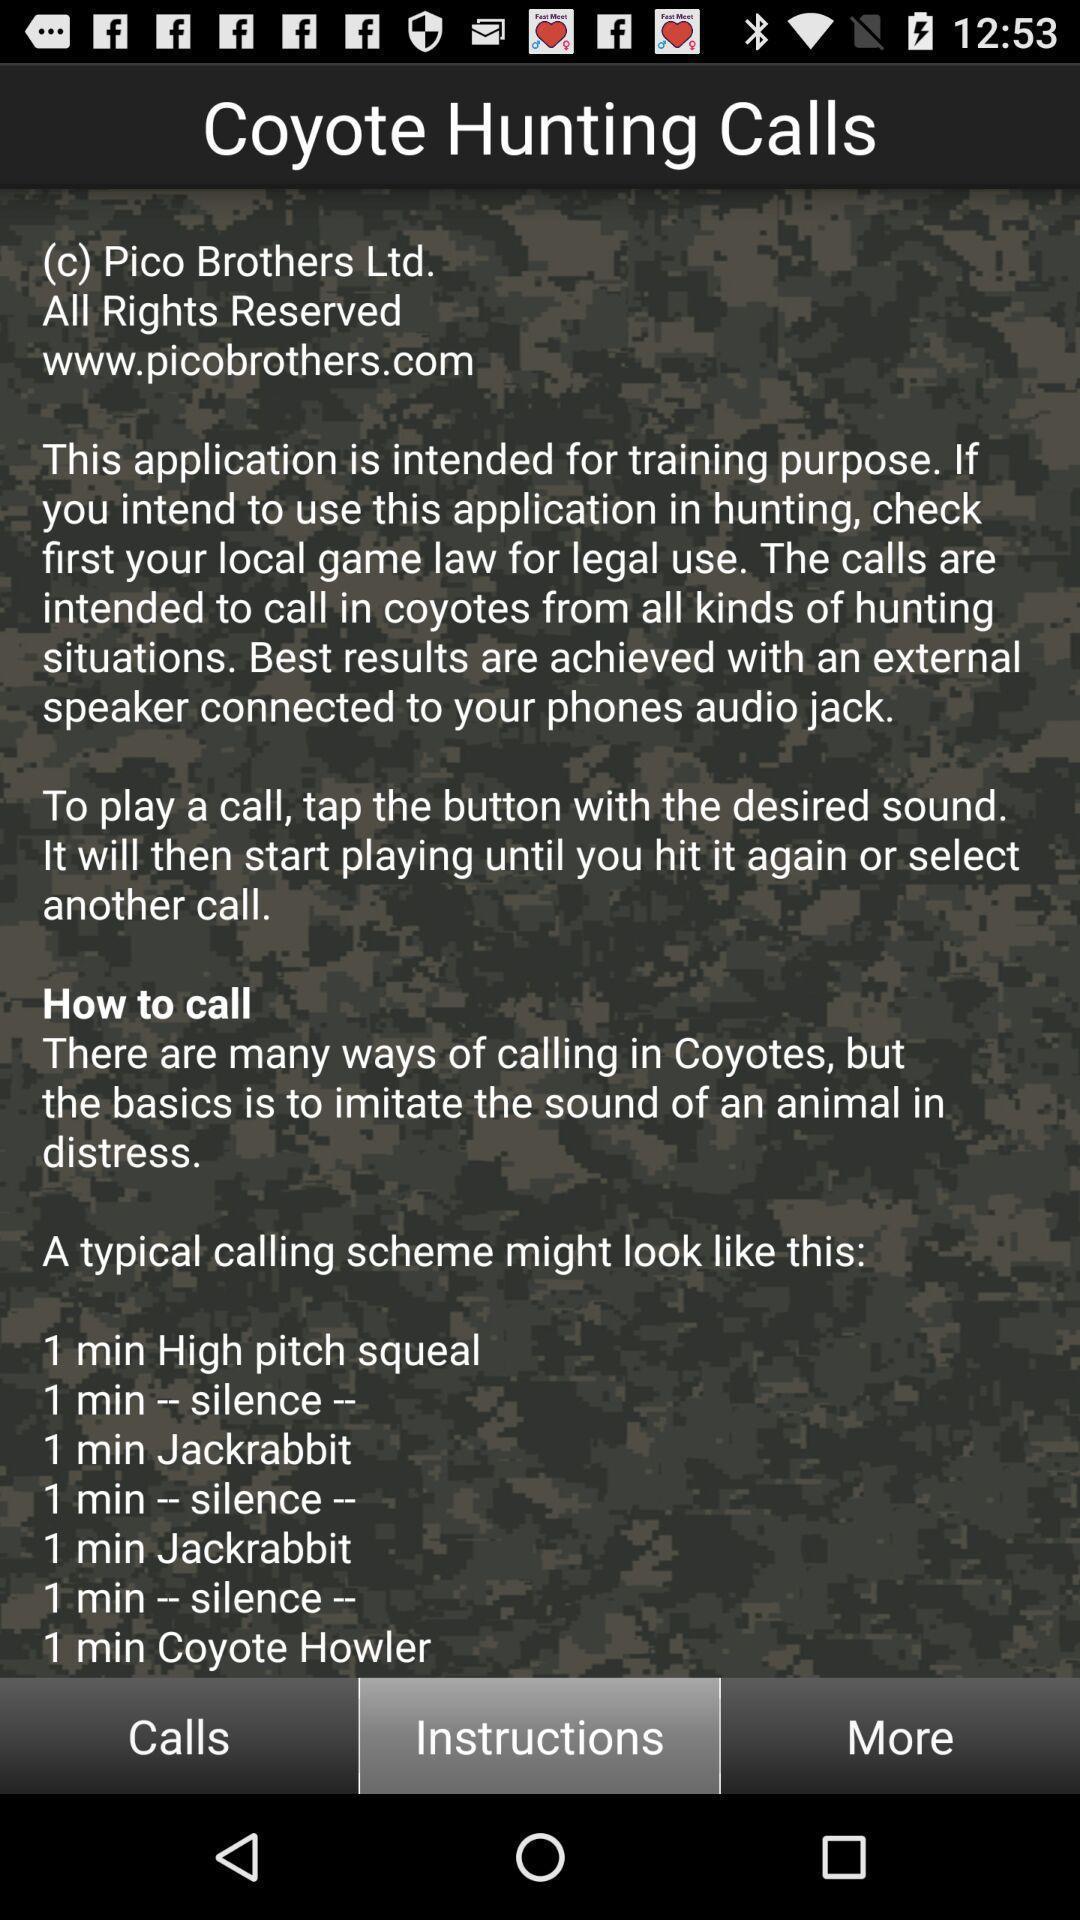Summarize the information in this screenshot. Page with instructions for a hunting app. 